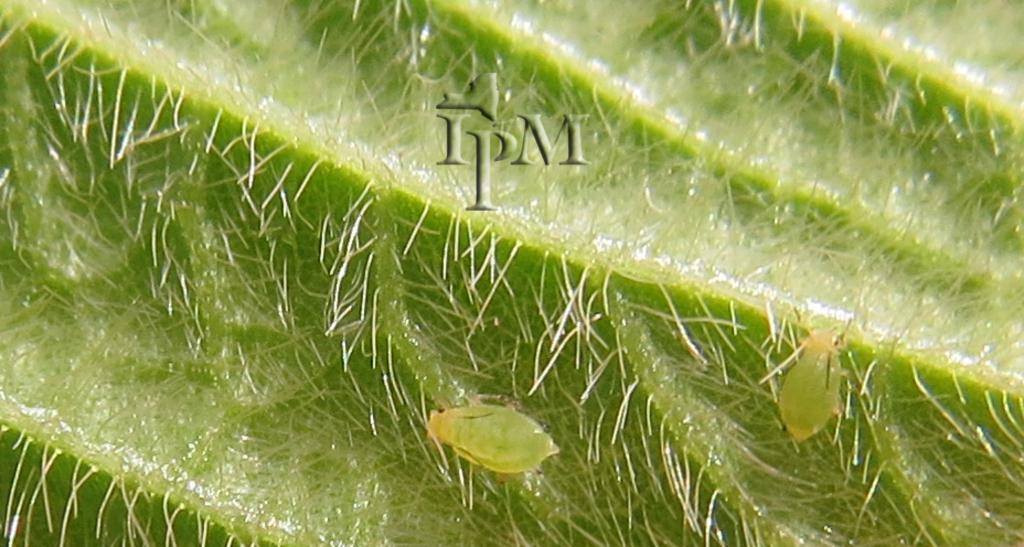What is present in the image? There are two insects in the image. Where are the insects located? The insects are on a green color leaf. What is the color of the insects? The insects are green in color. How many chairs can be seen in the image? There are no chairs present in the image; it features two insects on a green leaf. What type of yarn is being used by the insects in the image? There is no yarn present in the image, and the insects are not using any yarn. 